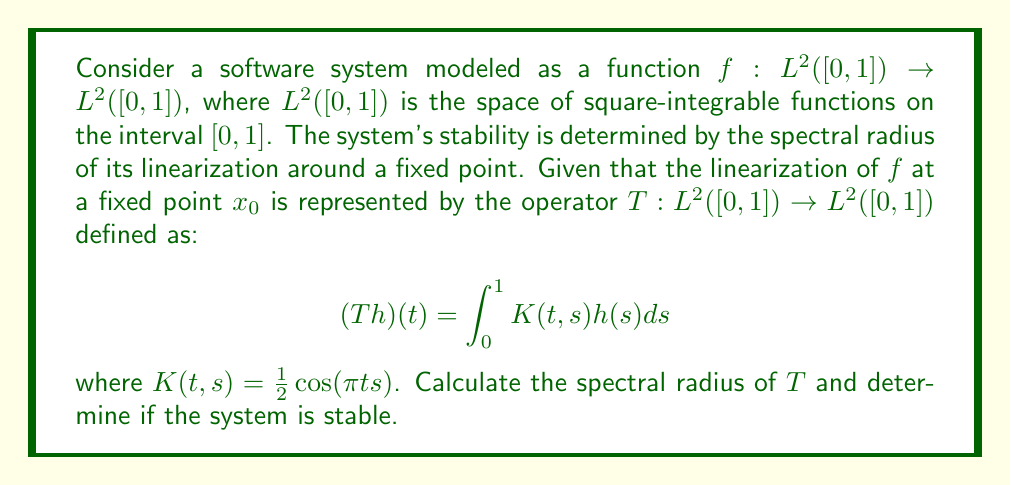Can you answer this question? To solve this problem, we'll follow these steps:

1) First, we need to understand that the spectral radius of an operator $T$ is defined as:

   $$\rho(T) = \sup\{|\lambda| : \lambda \in \sigma(T)\}$$

   where $\sigma(T)$ is the spectrum of $T$.

2) For compact operators on Hilbert spaces (which our integral operator is), the spectral radius is equal to the operator norm:

   $$\rho(T) = \|T\|$$

3) For integral operators, we can use the following theorem:
   If $T$ is an integral operator with kernel $K(t,s)$, then:

   $$\|T\|^2 \leq \int_0^1 \int_0^1 |K(t,s)|^2 dtds$$

4) Let's calculate this double integral:

   $$\begin{align*}
   \|T\|^2 &\leq \int_0^1 \int_0^1 |\frac{1}{2}\cos(\pi t s)|^2 dtds \\
   &= \frac{1}{4} \int_0^1 \int_0^1 \cos^2(\pi t s) dtds \\
   &= \frac{1}{4} \int_0^1 \int_0^1 \frac{1 + \cos(2\pi t s)}{2} dtds \\
   &= \frac{1}{8} \int_0^1 \int_0^1 (1 + \cos(2\pi t s)) dtds \\
   &= \frac{1}{8} \left[s + \frac{\sin(2\pi t s)}{2\pi t}\right]_0^1 \bigg|_0^1 \\
   &= \frac{1}{8} \left[1 + \frac{\sin(2\pi t)}{2\pi t}\right]_0^1 \\
   &= \frac{1}{8} \left(1 + \frac{\sin(2\pi)}{2\pi}\right) \\
   &= \frac{1}{8}
   \end{align*}$$

5) Therefore, $\|T\| \leq \frac{1}{2\sqrt{2}}$.

6) For stability, we need the spectral radius to be less than 1. Since $\frac{1}{2\sqrt{2}} \approx 0.3536 < 1$, the system is stable.
Answer: The spectral radius of $T$ is at most $\frac{1}{2\sqrt{2}} \approx 0.3536$. Since this is less than 1, the system is stable. 